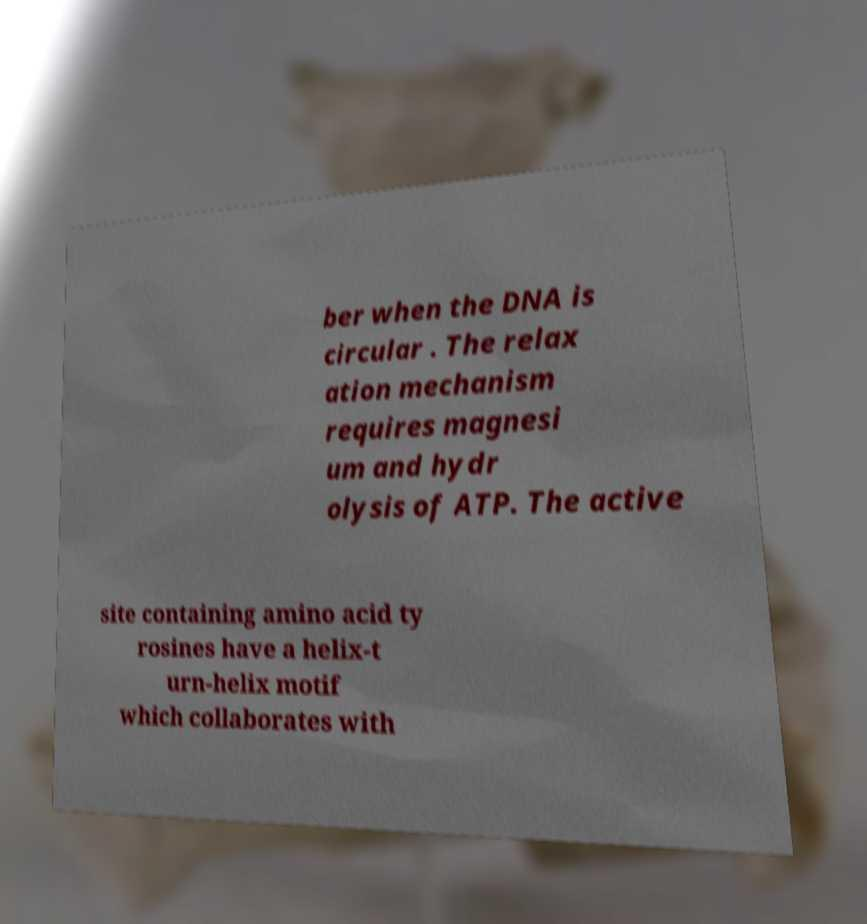What messages or text are displayed in this image? I need them in a readable, typed format. ber when the DNA is circular . The relax ation mechanism requires magnesi um and hydr olysis of ATP. The active site containing amino acid ty rosines have a helix-t urn-helix motif which collaborates with 